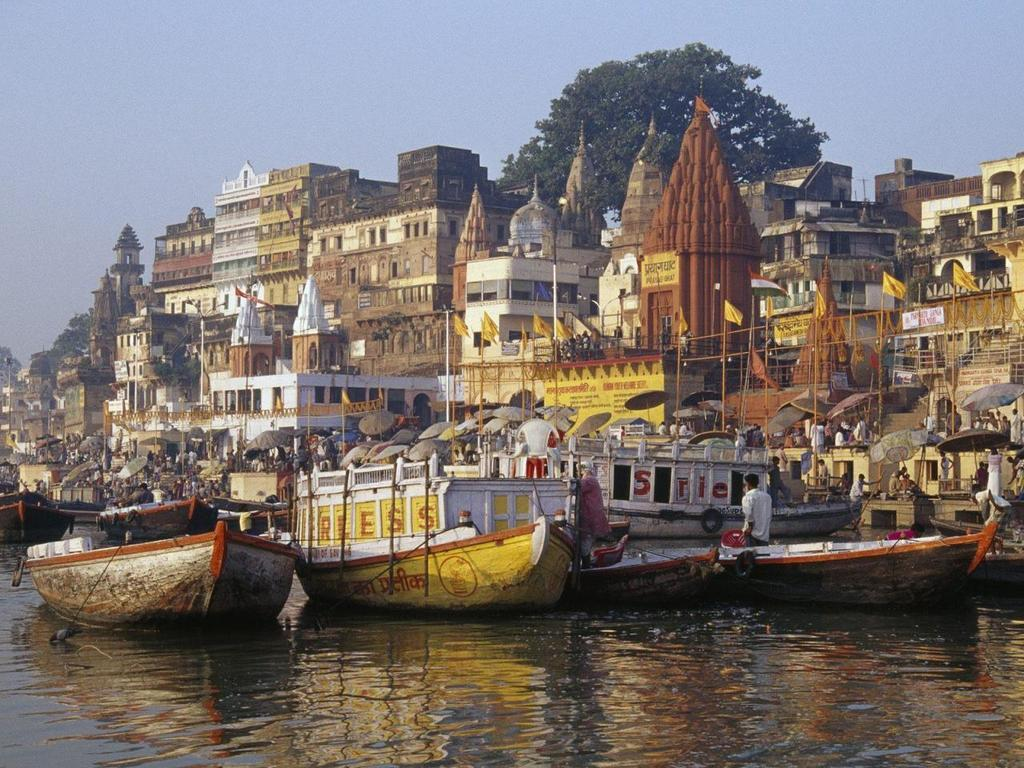What can be seen in the water in the image? There are many boats in the water. What is visible in the background of the image? There are flags with poles, umbrellas, buildings, trees, and the sky visible in the background. How many people can be seen in the image? There are many people in the image. What type of cow can be seen causing trouble in the image? There is no cow present in the image, nor is there any indication of trouble. 